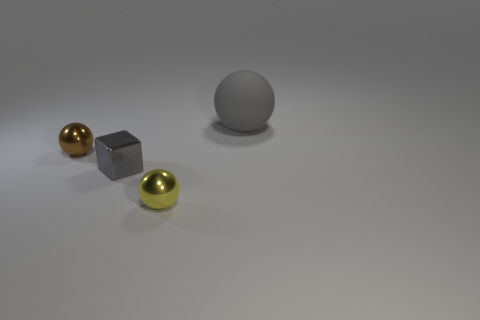There is a thing that is to the left of the large ball and to the right of the small metal cube; what is its color?
Provide a short and direct response. Yellow. What shape is the small gray object that is made of the same material as the small brown ball?
Your answer should be compact. Cube. How many objects are behind the tiny yellow object and on the left side of the gray ball?
Make the answer very short. 2. Are there any brown metal balls in front of the tiny block?
Your answer should be compact. No. Do the thing that is behind the brown metallic ball and the tiny metallic thing that is left of the tiny block have the same shape?
Give a very brief answer. Yes. How many objects are cyan matte cylinders or metal balls on the left side of the small yellow metallic ball?
Ensure brevity in your answer.  1. How many other things are there of the same shape as the small brown metal object?
Make the answer very short. 2. Does the sphere to the left of the yellow metallic ball have the same material as the yellow sphere?
Your response must be concise. Yes. What number of things are either large purple metal blocks or shiny balls?
Give a very brief answer. 2. There is another matte thing that is the same shape as the tiny brown thing; what is its size?
Make the answer very short. Large. 